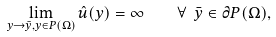Convert formula to latex. <formula><loc_0><loc_0><loc_500><loc_500>\lim _ { y \to \bar { y } , y \in P ( \Omega ) } \hat { u } ( y ) = \infty \quad \forall \ \bar { y } \in \partial P ( \Omega ) ,</formula> 